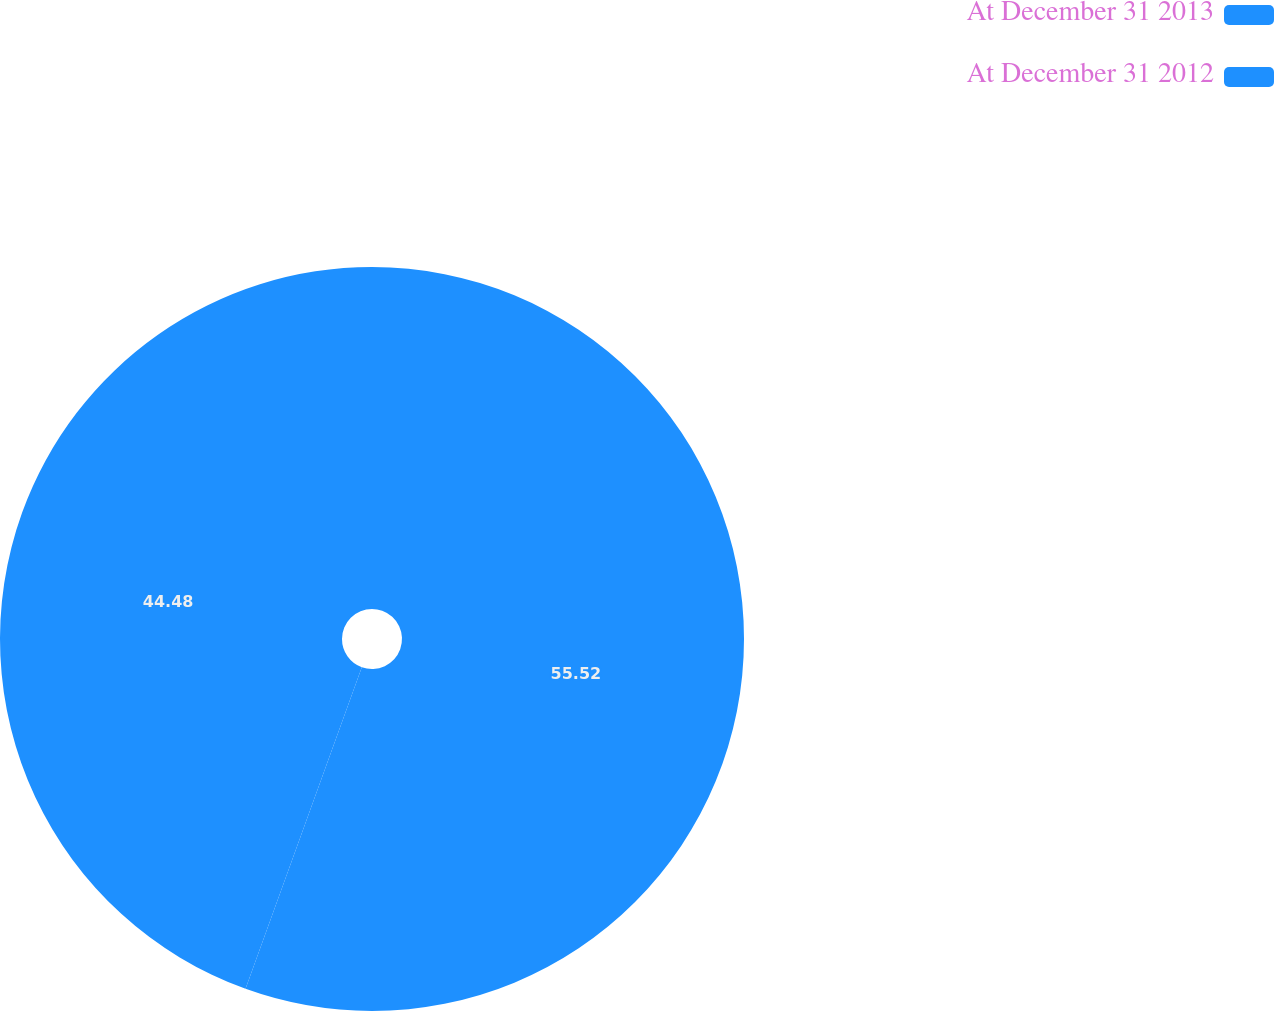<chart> <loc_0><loc_0><loc_500><loc_500><pie_chart><fcel>At December 31 2013<fcel>At December 31 2012<nl><fcel>55.52%<fcel>44.48%<nl></chart> 